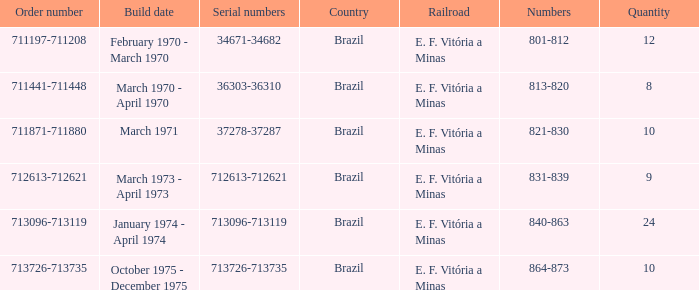What country has the order number 711871-711880? Brazil. 